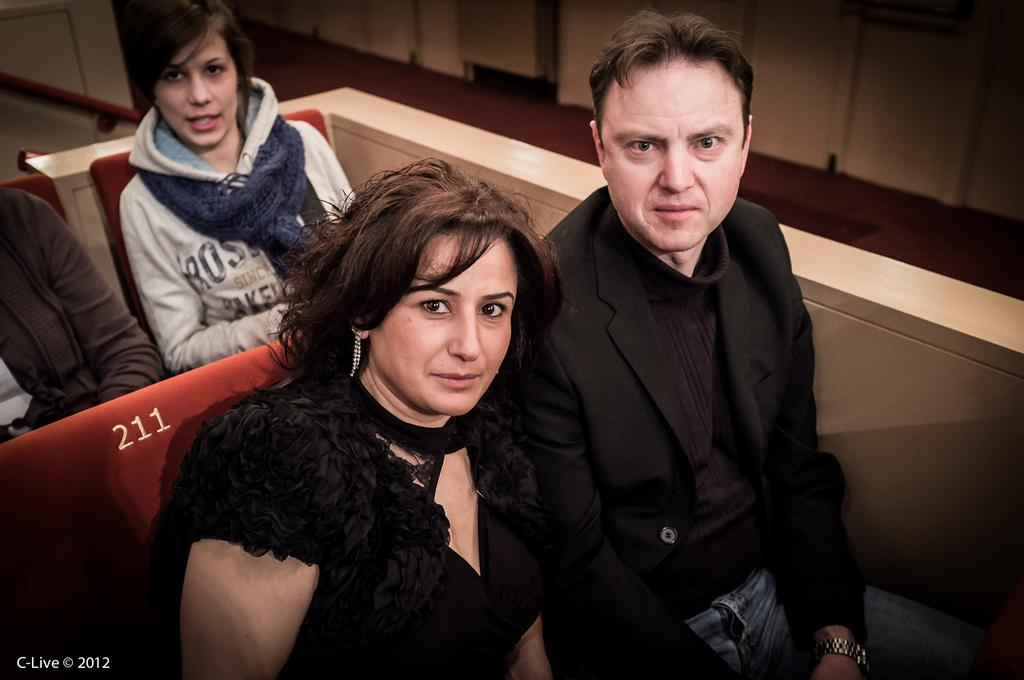What are the persons in the image doing? The persons in the image are sitting. What are the persons sitting on? There are chairs in the image for the persons to sit on. What is visible behind the persons? There is a wall in the image. What is the surface beneath the persons and chairs? There is a floor in the image. What type of coast can be seen in the image? There is no coast present in the image. How does the image relate to the concept of death? The image does not depict or reference any concept related to death. 